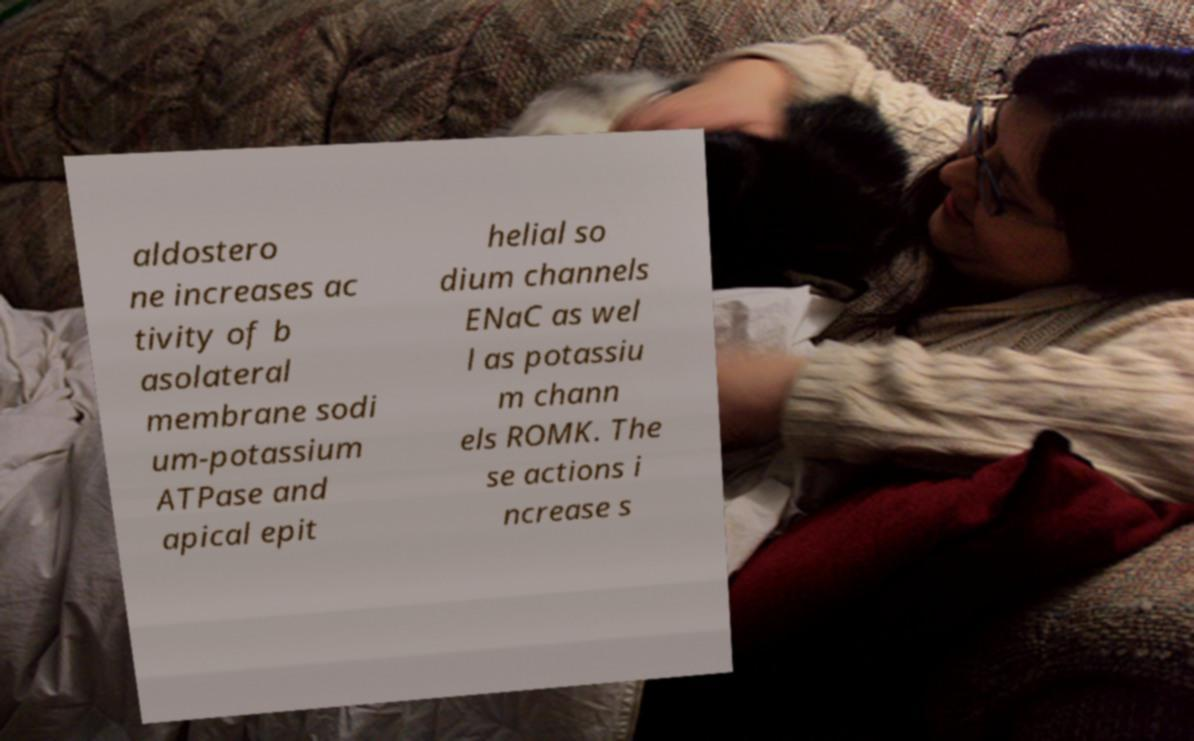What messages or text are displayed in this image? I need them in a readable, typed format. aldostero ne increases ac tivity of b asolateral membrane sodi um-potassium ATPase and apical epit helial so dium channels ENaC as wel l as potassiu m chann els ROMK. The se actions i ncrease s 